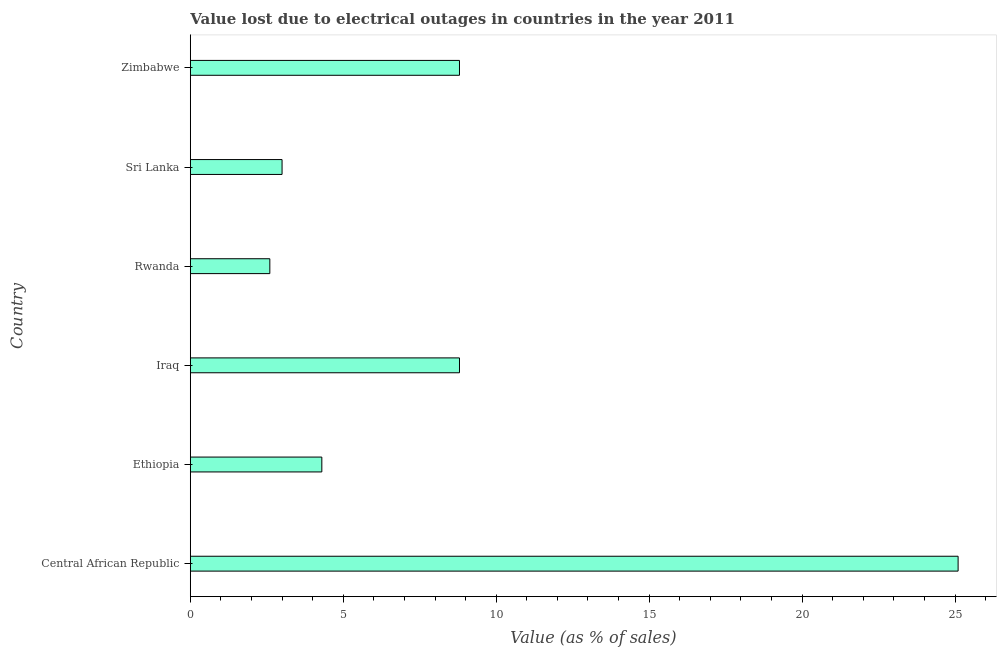What is the title of the graph?
Offer a very short reply. Value lost due to electrical outages in countries in the year 2011. What is the label or title of the X-axis?
Offer a terse response. Value (as % of sales). What is the label or title of the Y-axis?
Provide a succinct answer. Country. What is the value lost due to electrical outages in Sri Lanka?
Your answer should be very brief. 3. Across all countries, what is the maximum value lost due to electrical outages?
Ensure brevity in your answer.  25.1. In which country was the value lost due to electrical outages maximum?
Your response must be concise. Central African Republic. In which country was the value lost due to electrical outages minimum?
Give a very brief answer. Rwanda. What is the sum of the value lost due to electrical outages?
Make the answer very short. 52.6. What is the difference between the value lost due to electrical outages in Rwanda and Zimbabwe?
Offer a terse response. -6.2. What is the average value lost due to electrical outages per country?
Offer a very short reply. 8.77. What is the median value lost due to electrical outages?
Give a very brief answer. 6.55. What is the ratio of the value lost due to electrical outages in Central African Republic to that in Sri Lanka?
Your answer should be compact. 8.37. Is the value lost due to electrical outages in Sri Lanka less than that in Zimbabwe?
Provide a short and direct response. Yes. Is the difference between the value lost due to electrical outages in Rwanda and Sri Lanka greater than the difference between any two countries?
Provide a short and direct response. No. In how many countries, is the value lost due to electrical outages greater than the average value lost due to electrical outages taken over all countries?
Your answer should be very brief. 3. How many bars are there?
Keep it short and to the point. 6. Are all the bars in the graph horizontal?
Give a very brief answer. Yes. How many countries are there in the graph?
Your answer should be very brief. 6. What is the difference between two consecutive major ticks on the X-axis?
Your answer should be very brief. 5. Are the values on the major ticks of X-axis written in scientific E-notation?
Offer a very short reply. No. What is the Value (as % of sales) of Central African Republic?
Ensure brevity in your answer.  25.1. What is the Value (as % of sales) in Ethiopia?
Provide a succinct answer. 4.3. What is the Value (as % of sales) of Iraq?
Ensure brevity in your answer.  8.8. What is the Value (as % of sales) in Sri Lanka?
Your answer should be very brief. 3. What is the Value (as % of sales) in Zimbabwe?
Offer a very short reply. 8.8. What is the difference between the Value (as % of sales) in Central African Republic and Ethiopia?
Your response must be concise. 20.8. What is the difference between the Value (as % of sales) in Central African Republic and Sri Lanka?
Keep it short and to the point. 22.1. What is the difference between the Value (as % of sales) in Ethiopia and Iraq?
Make the answer very short. -4.5. What is the difference between the Value (as % of sales) in Iraq and Rwanda?
Offer a terse response. 6.2. What is the difference between the Value (as % of sales) in Iraq and Sri Lanka?
Offer a terse response. 5.8. What is the difference between the Value (as % of sales) in Iraq and Zimbabwe?
Provide a succinct answer. 0. What is the difference between the Value (as % of sales) in Rwanda and Sri Lanka?
Your response must be concise. -0.4. What is the difference between the Value (as % of sales) in Sri Lanka and Zimbabwe?
Ensure brevity in your answer.  -5.8. What is the ratio of the Value (as % of sales) in Central African Republic to that in Ethiopia?
Your answer should be very brief. 5.84. What is the ratio of the Value (as % of sales) in Central African Republic to that in Iraq?
Your answer should be very brief. 2.85. What is the ratio of the Value (as % of sales) in Central African Republic to that in Rwanda?
Your answer should be compact. 9.65. What is the ratio of the Value (as % of sales) in Central African Republic to that in Sri Lanka?
Provide a succinct answer. 8.37. What is the ratio of the Value (as % of sales) in Central African Republic to that in Zimbabwe?
Make the answer very short. 2.85. What is the ratio of the Value (as % of sales) in Ethiopia to that in Iraq?
Make the answer very short. 0.49. What is the ratio of the Value (as % of sales) in Ethiopia to that in Rwanda?
Ensure brevity in your answer.  1.65. What is the ratio of the Value (as % of sales) in Ethiopia to that in Sri Lanka?
Offer a very short reply. 1.43. What is the ratio of the Value (as % of sales) in Ethiopia to that in Zimbabwe?
Give a very brief answer. 0.49. What is the ratio of the Value (as % of sales) in Iraq to that in Rwanda?
Your answer should be very brief. 3.38. What is the ratio of the Value (as % of sales) in Iraq to that in Sri Lanka?
Offer a very short reply. 2.93. What is the ratio of the Value (as % of sales) in Iraq to that in Zimbabwe?
Offer a very short reply. 1. What is the ratio of the Value (as % of sales) in Rwanda to that in Sri Lanka?
Keep it short and to the point. 0.87. What is the ratio of the Value (as % of sales) in Rwanda to that in Zimbabwe?
Your answer should be compact. 0.29. What is the ratio of the Value (as % of sales) in Sri Lanka to that in Zimbabwe?
Keep it short and to the point. 0.34. 